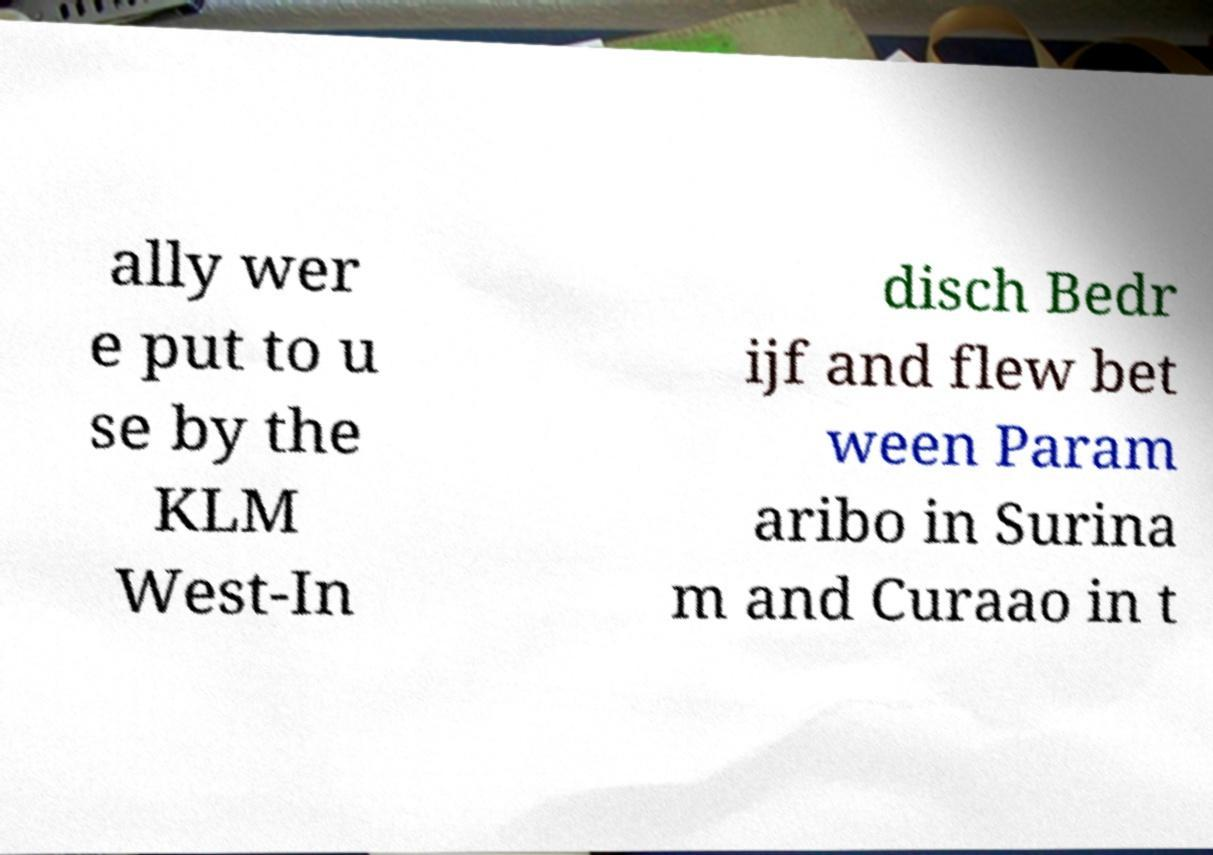Please read and relay the text visible in this image. What does it say? ally wer e put to u se by the KLM West-In disch Bedr ijf and flew bet ween Param aribo in Surina m and Curaao in t 